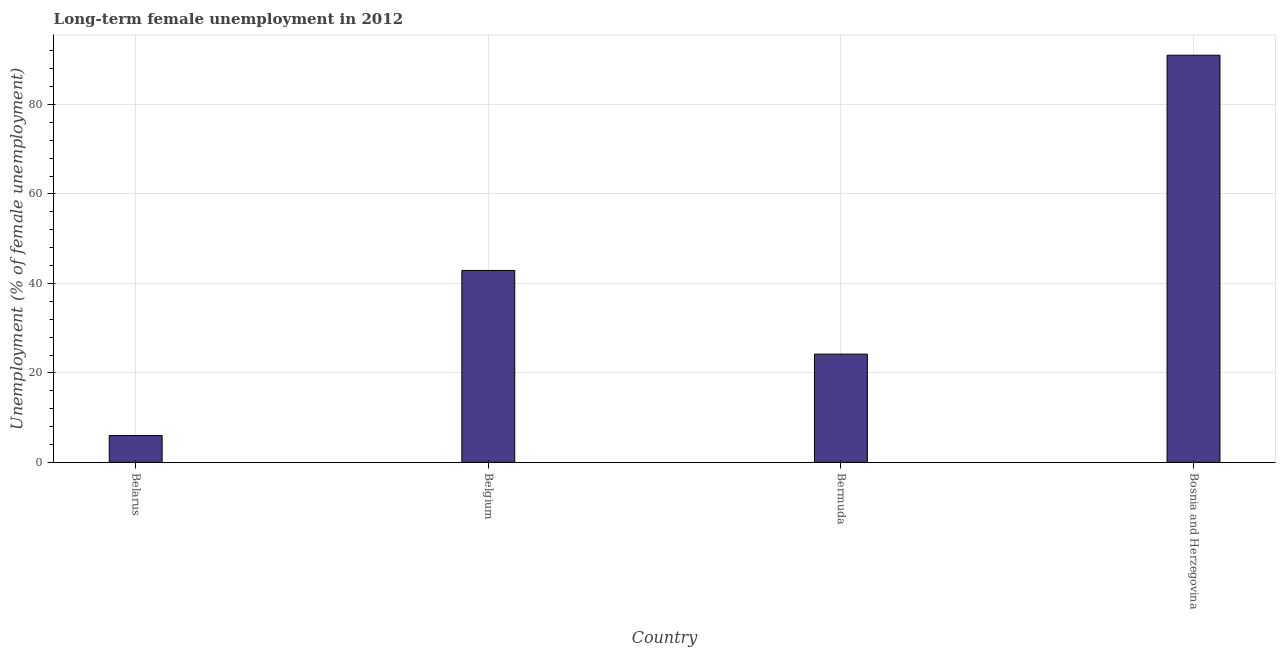Does the graph contain grids?
Keep it short and to the point. Yes. What is the title of the graph?
Ensure brevity in your answer.  Long-term female unemployment in 2012. What is the label or title of the Y-axis?
Ensure brevity in your answer.  Unemployment (% of female unemployment). What is the long-term female unemployment in Belgium?
Make the answer very short. 42.9. Across all countries, what is the maximum long-term female unemployment?
Your answer should be very brief. 91. Across all countries, what is the minimum long-term female unemployment?
Offer a terse response. 6. In which country was the long-term female unemployment maximum?
Provide a short and direct response. Bosnia and Herzegovina. In which country was the long-term female unemployment minimum?
Provide a succinct answer. Belarus. What is the sum of the long-term female unemployment?
Your answer should be compact. 164.1. What is the difference between the long-term female unemployment in Belarus and Belgium?
Your answer should be very brief. -36.9. What is the average long-term female unemployment per country?
Offer a terse response. 41.02. What is the median long-term female unemployment?
Offer a terse response. 33.55. In how many countries, is the long-term female unemployment greater than 88 %?
Make the answer very short. 1. What is the ratio of the long-term female unemployment in Belgium to that in Bermuda?
Your response must be concise. 1.77. What is the difference between the highest and the second highest long-term female unemployment?
Provide a succinct answer. 48.1. Is the sum of the long-term female unemployment in Belgium and Bosnia and Herzegovina greater than the maximum long-term female unemployment across all countries?
Provide a succinct answer. Yes. What is the difference between the highest and the lowest long-term female unemployment?
Give a very brief answer. 85. In how many countries, is the long-term female unemployment greater than the average long-term female unemployment taken over all countries?
Provide a succinct answer. 2. How many bars are there?
Provide a short and direct response. 4. Are all the bars in the graph horizontal?
Keep it short and to the point. No. How many countries are there in the graph?
Provide a short and direct response. 4. What is the Unemployment (% of female unemployment) in Belarus?
Give a very brief answer. 6. What is the Unemployment (% of female unemployment) in Belgium?
Keep it short and to the point. 42.9. What is the Unemployment (% of female unemployment) in Bermuda?
Offer a very short reply. 24.2. What is the Unemployment (% of female unemployment) of Bosnia and Herzegovina?
Give a very brief answer. 91. What is the difference between the Unemployment (% of female unemployment) in Belarus and Belgium?
Your response must be concise. -36.9. What is the difference between the Unemployment (% of female unemployment) in Belarus and Bermuda?
Your response must be concise. -18.2. What is the difference between the Unemployment (% of female unemployment) in Belarus and Bosnia and Herzegovina?
Provide a short and direct response. -85. What is the difference between the Unemployment (% of female unemployment) in Belgium and Bermuda?
Offer a very short reply. 18.7. What is the difference between the Unemployment (% of female unemployment) in Belgium and Bosnia and Herzegovina?
Offer a very short reply. -48.1. What is the difference between the Unemployment (% of female unemployment) in Bermuda and Bosnia and Herzegovina?
Give a very brief answer. -66.8. What is the ratio of the Unemployment (% of female unemployment) in Belarus to that in Belgium?
Your answer should be compact. 0.14. What is the ratio of the Unemployment (% of female unemployment) in Belarus to that in Bermuda?
Your answer should be compact. 0.25. What is the ratio of the Unemployment (% of female unemployment) in Belarus to that in Bosnia and Herzegovina?
Offer a very short reply. 0.07. What is the ratio of the Unemployment (% of female unemployment) in Belgium to that in Bermuda?
Provide a succinct answer. 1.77. What is the ratio of the Unemployment (% of female unemployment) in Belgium to that in Bosnia and Herzegovina?
Provide a short and direct response. 0.47. What is the ratio of the Unemployment (% of female unemployment) in Bermuda to that in Bosnia and Herzegovina?
Your answer should be very brief. 0.27. 